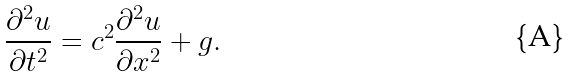Convert formula to latex. <formula><loc_0><loc_0><loc_500><loc_500>\frac { \partial ^ { 2 } u } { \partial t ^ { 2 } } = c ^ { 2 } \frac { \partial ^ { 2 } u } { \partial x ^ { 2 } } + g .</formula> 